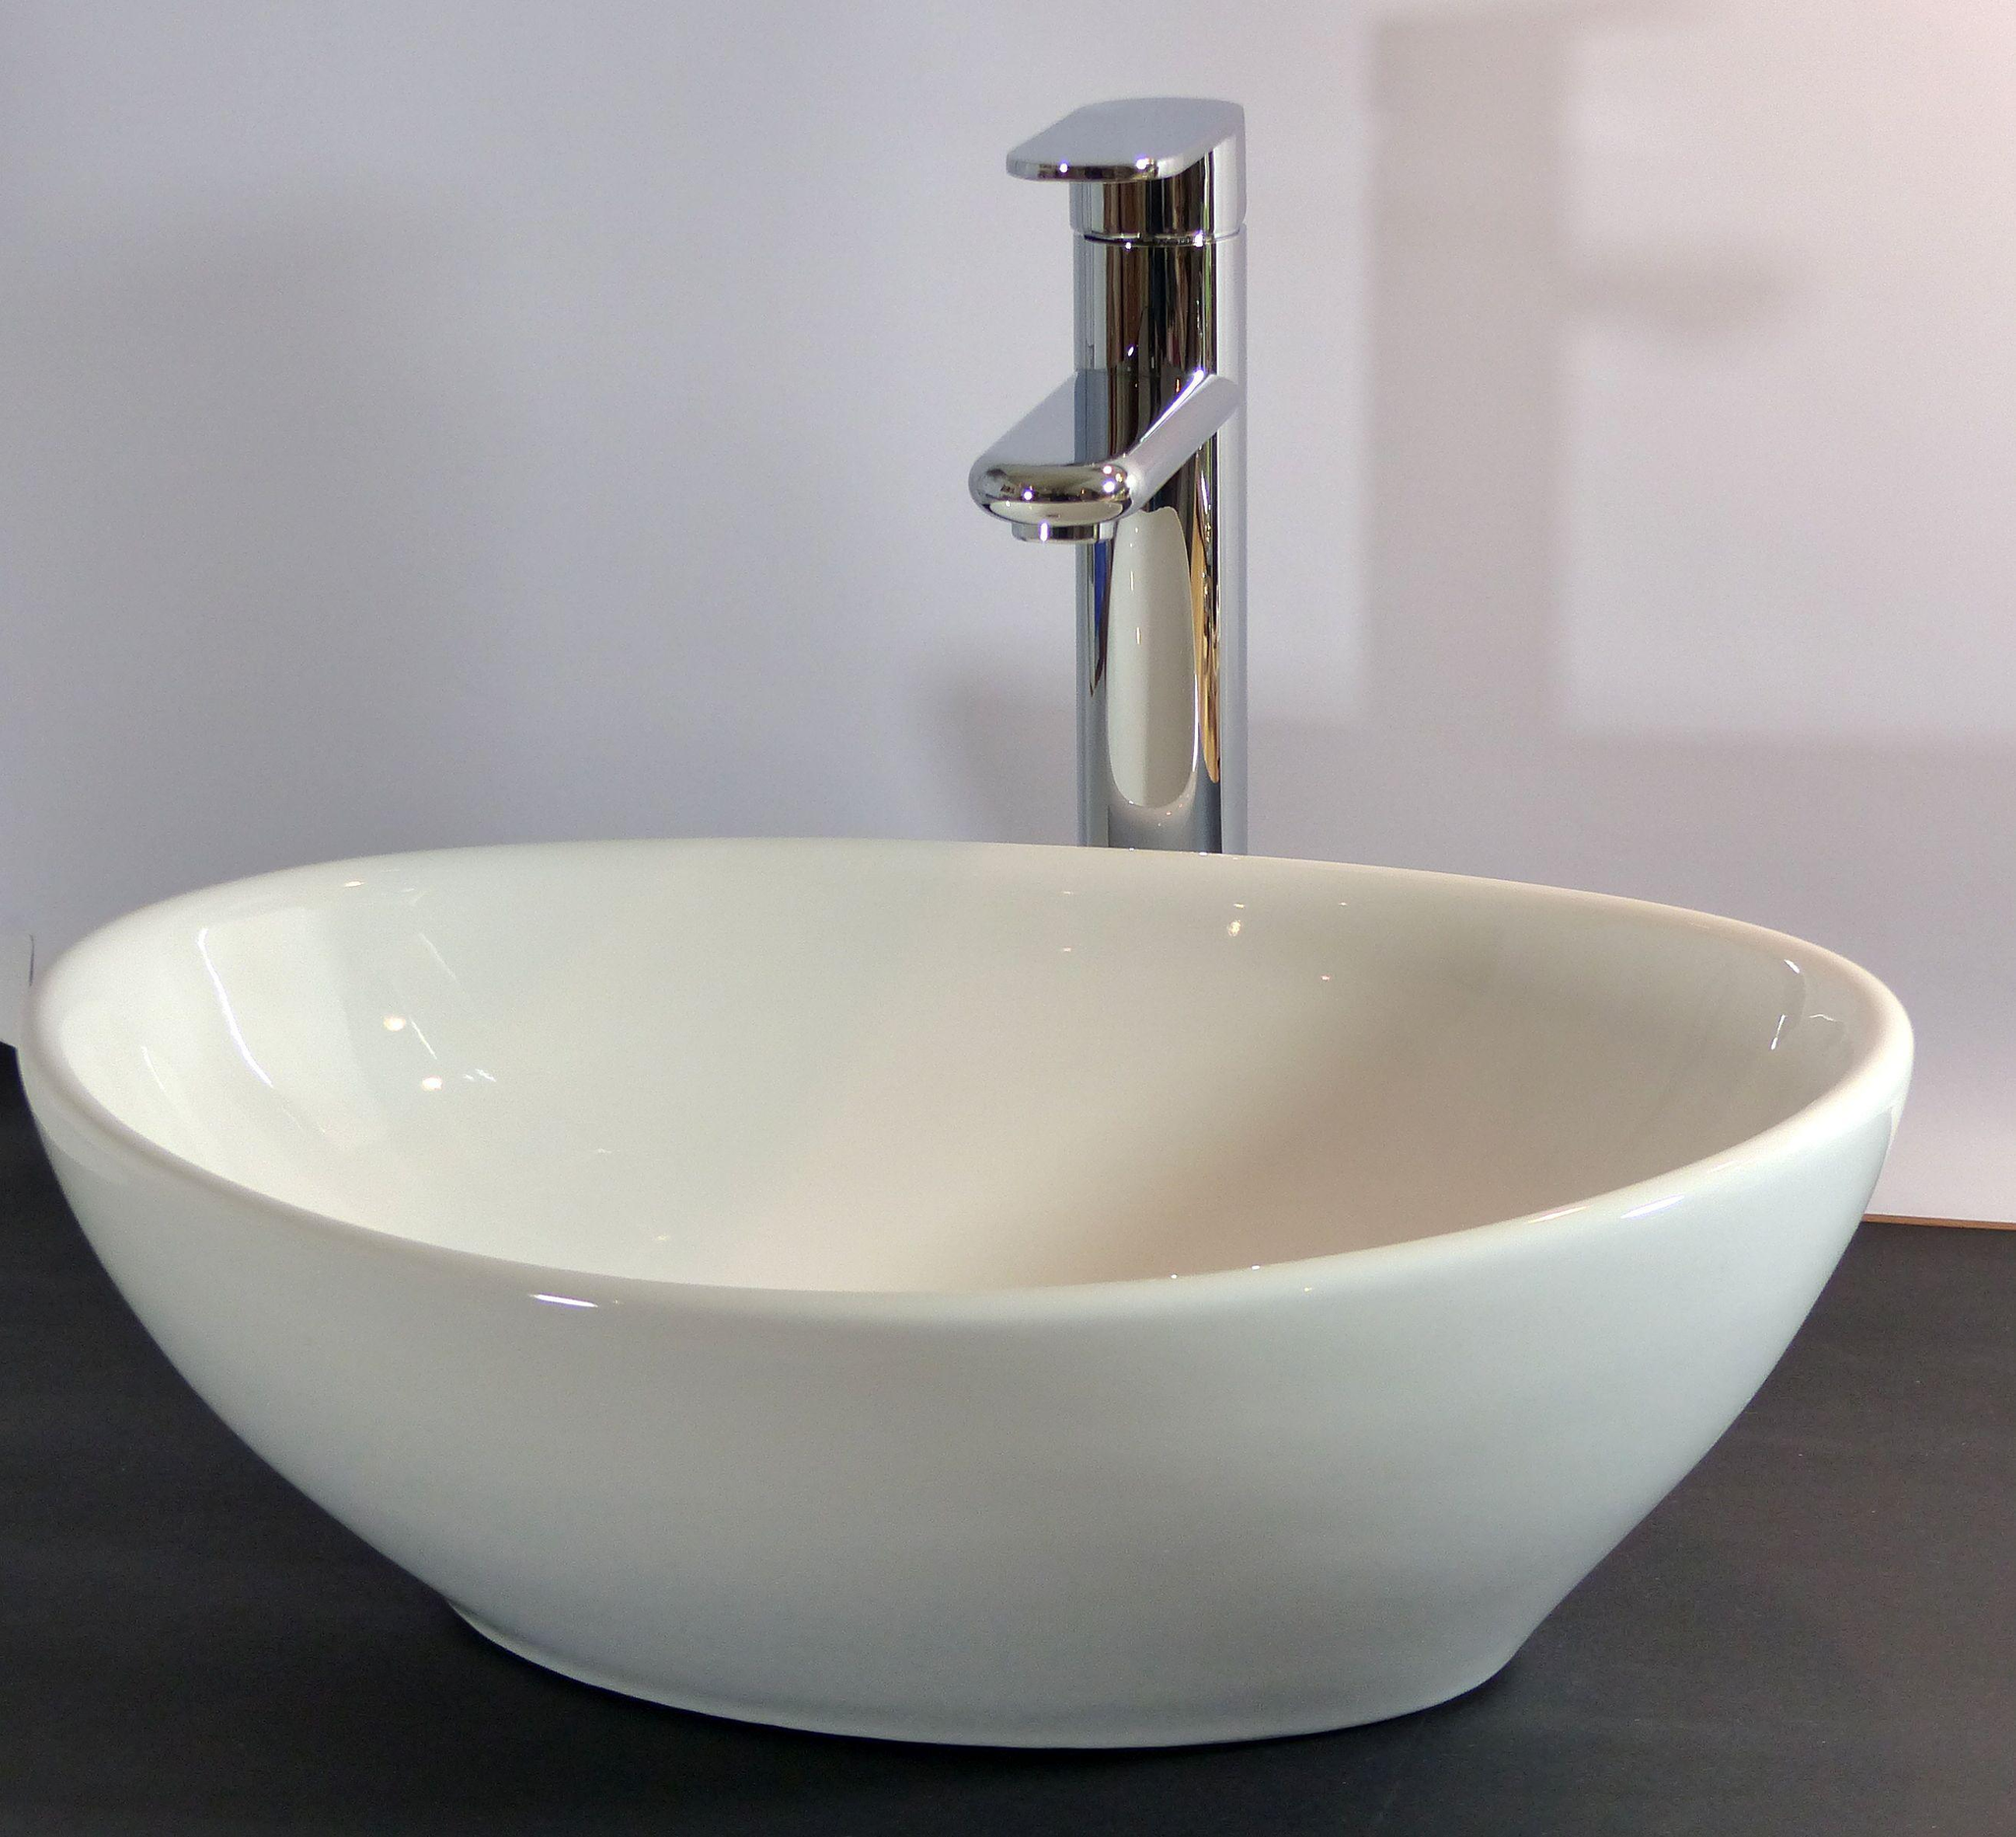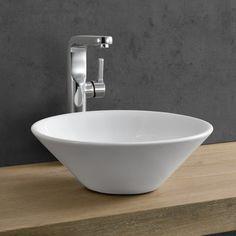The first image is the image on the left, the second image is the image on the right. Evaluate the accuracy of this statement regarding the images: "Each image shows a white bowl-shaped sink that sits on top of a counter.". Is it true? Answer yes or no. Yes. The first image is the image on the left, the second image is the image on the right. Analyze the images presented: Is the assertion "The wall behind the sink is gray in one of the images." valid? Answer yes or no. Yes. 